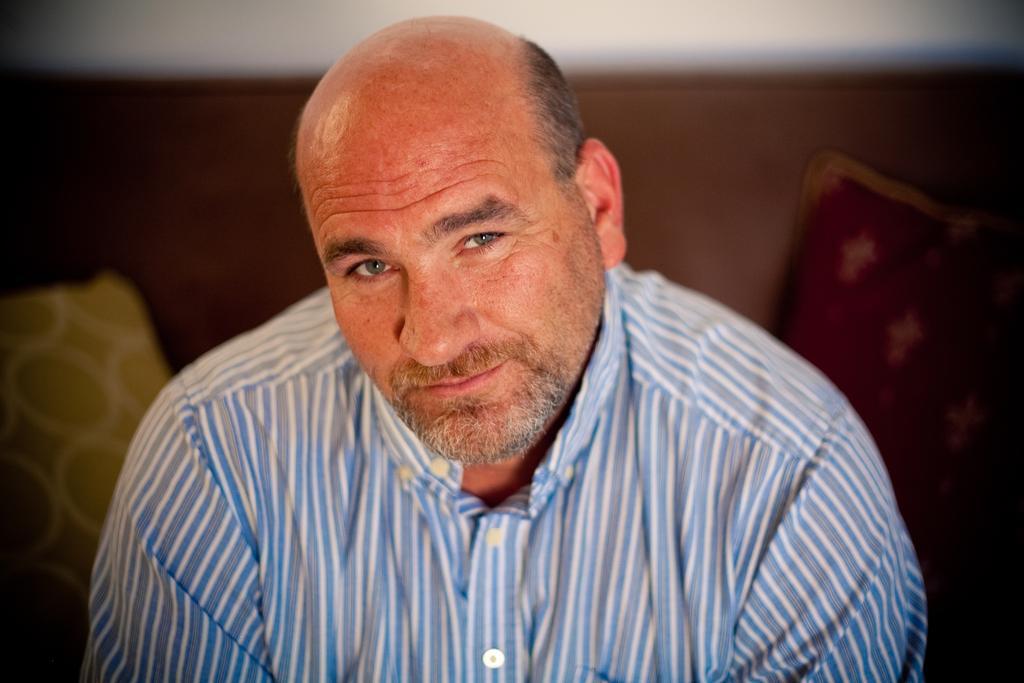In one or two sentences, can you explain what this image depicts? In this image, I can see the man smiling. He wore a shirt. In the background, that looks like a couch with two cushions on it. 